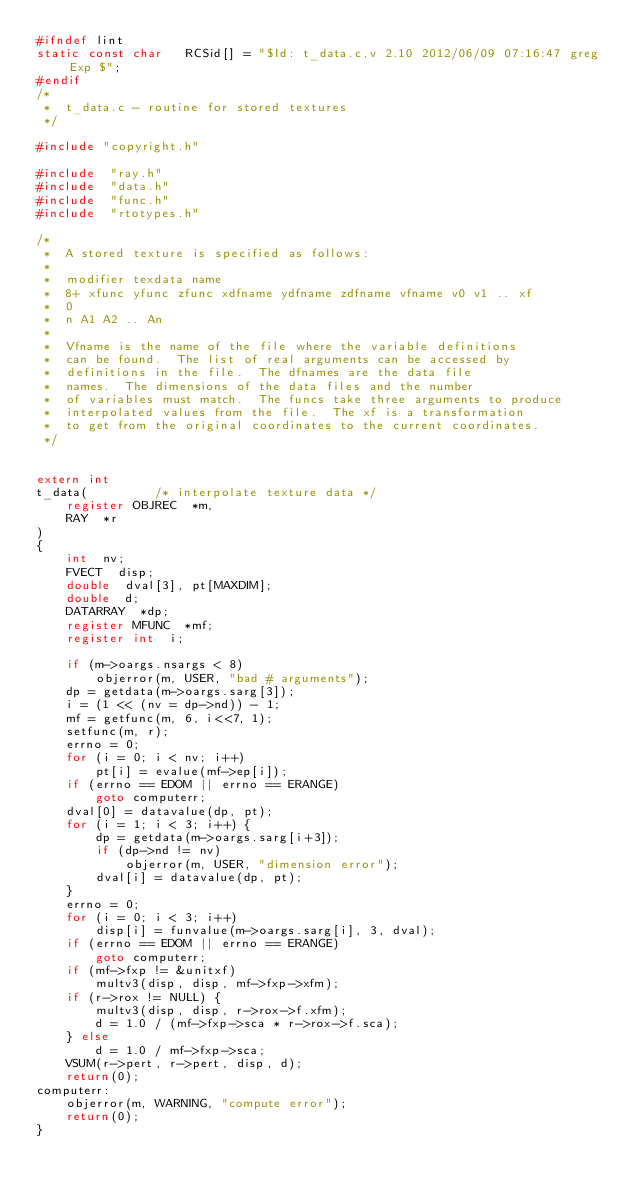<code> <loc_0><loc_0><loc_500><loc_500><_C_>#ifndef lint
static const char	RCSid[] = "$Id: t_data.c,v 2.10 2012/06/09 07:16:47 greg Exp $";
#endif
/*
 *  t_data.c - routine for stored textures
 */

#include "copyright.h"

#include  "ray.h"
#include  "data.h"
#include  "func.h"
#include  "rtotypes.h"

/*
 *	A stored texture is specified as follows:
 *
 *	modifier texdata name
 *	8+ xfunc yfunc zfunc xdfname ydfname zdfname vfname v0 v1 .. xf
 *	0
 *	n A1 A2 .. An
 *
 *  Vfname is the name of the file where the variable definitions
 *  can be found.  The list of real arguments can be accessed by
 *  definitions in the file.  The dfnames are the data file
 *  names.  The dimensions of the data files and the number
 *  of variables must match.  The funcs take three arguments to produce
 *  interpolated values from the file.  The xf is a transformation
 *  to get from the original coordinates to the current coordinates.
 */


extern int
t_data(			/* interpolate texture data */
	register OBJREC  *m,
	RAY  *r
)
{
	int  nv;
	FVECT  disp;
	double  dval[3], pt[MAXDIM];
	double  d;
	DATARRAY  *dp;
	register MFUNC  *mf;
	register int  i;

	if (m->oargs.nsargs < 8)
		objerror(m, USER, "bad # arguments");
	dp = getdata(m->oargs.sarg[3]);
	i = (1 << (nv = dp->nd)) - 1;
	mf = getfunc(m, 6, i<<7, 1);
	setfunc(m, r);
	errno = 0;
	for (i = 0; i < nv; i++)
		pt[i] = evalue(mf->ep[i]);
	if (errno == EDOM || errno == ERANGE)
		goto computerr;
	dval[0] = datavalue(dp, pt);
	for (i = 1; i < 3; i++) {
		dp = getdata(m->oargs.sarg[i+3]);
		if (dp->nd != nv)
			objerror(m, USER, "dimension error");
		dval[i] = datavalue(dp, pt);
	}
	errno = 0;
	for (i = 0; i < 3; i++)
		disp[i] = funvalue(m->oargs.sarg[i], 3, dval);
	if (errno == EDOM || errno == ERANGE)
		goto computerr;
	if (mf->fxp != &unitxf)
		multv3(disp, disp, mf->fxp->xfm);
	if (r->rox != NULL) {
		multv3(disp, disp, r->rox->f.xfm);
		d = 1.0 / (mf->fxp->sca * r->rox->f.sca);
	} else
		d = 1.0 / mf->fxp->sca;
	VSUM(r->pert, r->pert, disp, d);
	return(0);
computerr:
	objerror(m, WARNING, "compute error");
	return(0);
}
</code> 